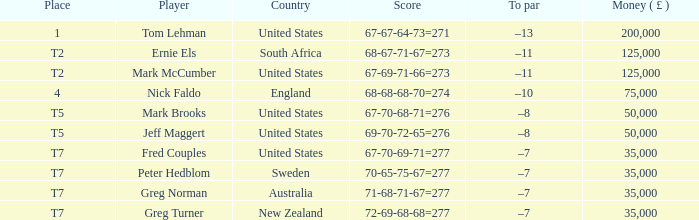What is the points, when country is "united states", and when player is "mark brooks"? 67-70-68-71=276. 